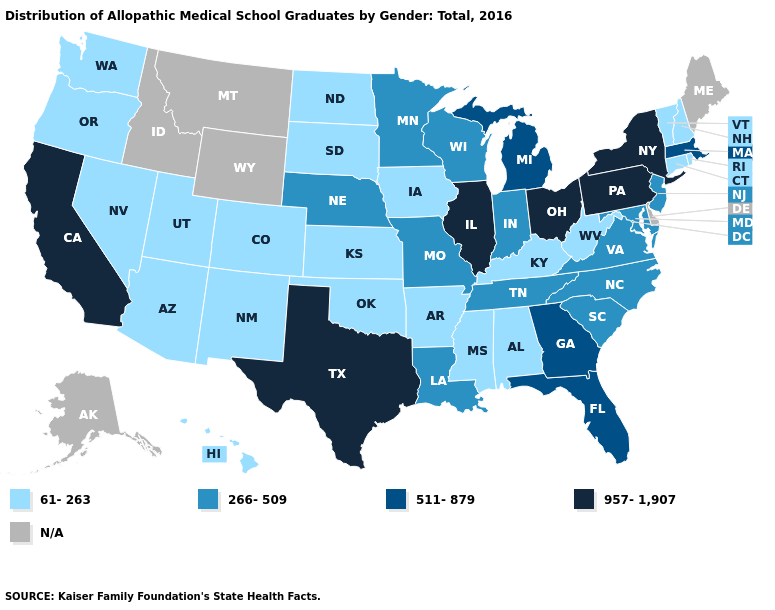What is the lowest value in the USA?
Concise answer only. 61-263. Is the legend a continuous bar?
Answer briefly. No. Does North Carolina have the lowest value in the South?
Write a very short answer. No. What is the lowest value in states that border Indiana?
Write a very short answer. 61-263. What is the value of Georgia?
Short answer required. 511-879. What is the value of Illinois?
Keep it brief. 957-1,907. What is the value of Colorado?
Give a very brief answer. 61-263. Name the states that have a value in the range 511-879?
Give a very brief answer. Florida, Georgia, Massachusetts, Michigan. Which states hav the highest value in the MidWest?
Quick response, please. Illinois, Ohio. What is the value of Indiana?
Quick response, please. 266-509. What is the value of Indiana?
Be succinct. 266-509. What is the lowest value in states that border Minnesota?
Be succinct. 61-263. What is the lowest value in states that border Maine?
Answer briefly. 61-263. What is the value of Idaho?
Short answer required. N/A. Which states hav the highest value in the MidWest?
Write a very short answer. Illinois, Ohio. 